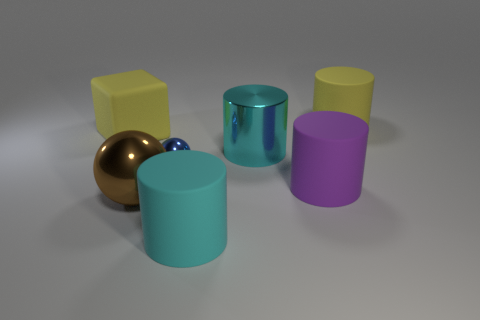Add 2 large purple rubber cylinders. How many objects exist? 9 Subtract all cubes. How many objects are left? 6 Add 6 big gray cylinders. How many big gray cylinders exist? 6 Subtract 0 purple balls. How many objects are left? 7 Subtract all small cyan metallic blocks. Subtract all big cyan matte things. How many objects are left? 6 Add 2 large yellow rubber cubes. How many large yellow rubber cubes are left? 3 